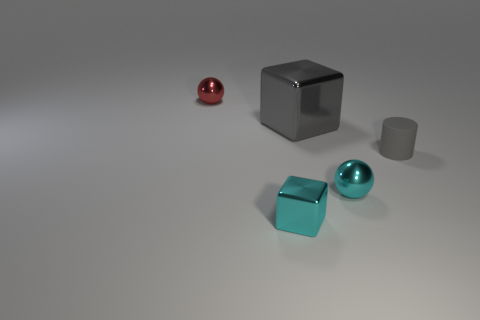Is the shape of the tiny shiny object behind the gray cylinder the same as  the large gray object?
Provide a succinct answer. No. The tiny object that is left of the block to the left of the big metallic cube is what shape?
Your answer should be very brief. Sphere. Is there anything else that has the same shape as the tiny gray thing?
Offer a terse response. No. There is a tiny rubber object; is its color the same as the tiny metallic object behind the tiny matte object?
Ensure brevity in your answer.  No. What shape is the shiny thing that is to the left of the cyan metal ball and in front of the matte thing?
Your response must be concise. Cube. Are there fewer red balls than cyan rubber spheres?
Your response must be concise. No. Are any blue matte blocks visible?
Keep it short and to the point. No. What number of other objects are the same size as the gray metal thing?
Provide a succinct answer. 0. Are the cylinder and the sphere that is to the left of the small cyan metallic cube made of the same material?
Give a very brief answer. No. Are there an equal number of small red shiny things in front of the red object and tiny cyan things that are in front of the cyan metal block?
Offer a very short reply. Yes. 